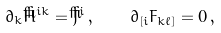Convert formula to latex. <formula><loc_0><loc_0><loc_500><loc_500>\partial _ { k } \check { H } ^ { i k } = \check { J } ^ { i } \, , \quad \partial _ { [ i } F _ { k \ell ] } = 0 \, ,</formula> 